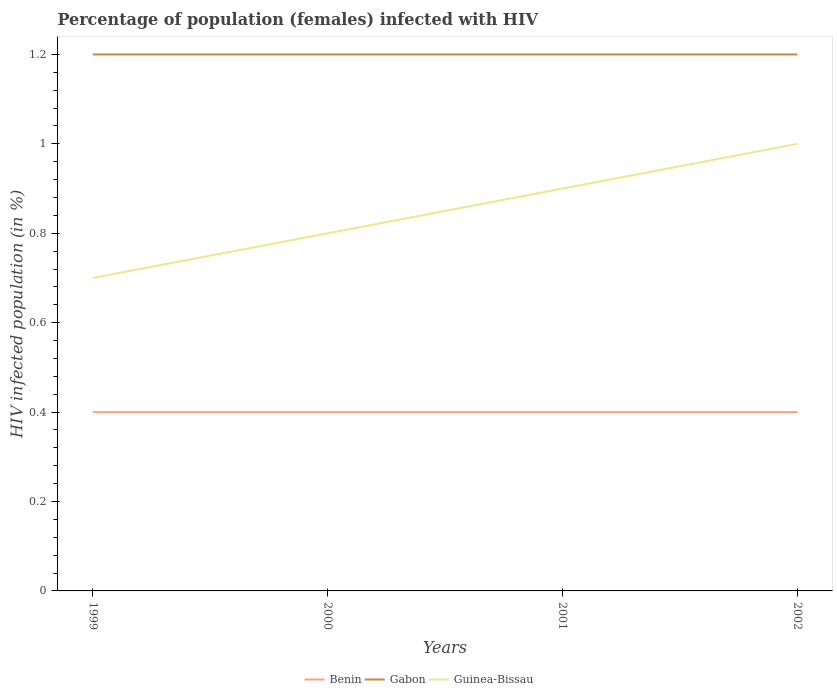Does the line corresponding to Gabon intersect with the line corresponding to Guinea-Bissau?
Your answer should be very brief. No. What is the total percentage of HIV infected female population in Benin in the graph?
Your answer should be very brief. 0. What is the difference between the highest and the second highest percentage of HIV infected female population in Guinea-Bissau?
Offer a very short reply. 0.3. What is the difference between the highest and the lowest percentage of HIV infected female population in Guinea-Bissau?
Ensure brevity in your answer.  2. Is the percentage of HIV infected female population in Guinea-Bissau strictly greater than the percentage of HIV infected female population in Gabon over the years?
Your response must be concise. Yes. Are the values on the major ticks of Y-axis written in scientific E-notation?
Your answer should be compact. No. Does the graph contain any zero values?
Your answer should be very brief. No. How are the legend labels stacked?
Provide a succinct answer. Horizontal. What is the title of the graph?
Your response must be concise. Percentage of population (females) infected with HIV. What is the label or title of the X-axis?
Your answer should be compact. Years. What is the label or title of the Y-axis?
Offer a terse response. HIV infected population (in %). What is the HIV infected population (in %) in Guinea-Bissau in 1999?
Provide a short and direct response. 0.7. What is the HIV infected population (in %) in Benin in 2000?
Offer a terse response. 0.4. What is the HIV infected population (in %) in Gabon in 2001?
Make the answer very short. 1.2. What is the HIV infected population (in %) of Guinea-Bissau in 2001?
Keep it short and to the point. 0.9. What is the HIV infected population (in %) in Guinea-Bissau in 2002?
Your answer should be compact. 1. Across all years, what is the maximum HIV infected population (in %) of Guinea-Bissau?
Your answer should be very brief. 1. Across all years, what is the minimum HIV infected population (in %) in Benin?
Provide a succinct answer. 0.4. Across all years, what is the minimum HIV infected population (in %) of Gabon?
Provide a short and direct response. 1.2. What is the total HIV infected population (in %) of Gabon in the graph?
Make the answer very short. 4.8. What is the difference between the HIV infected population (in %) of Benin in 1999 and that in 2000?
Ensure brevity in your answer.  0. What is the difference between the HIV infected population (in %) in Gabon in 1999 and that in 2000?
Provide a short and direct response. 0. What is the difference between the HIV infected population (in %) of Benin in 1999 and that in 2001?
Offer a very short reply. 0. What is the difference between the HIV infected population (in %) in Benin in 1999 and that in 2002?
Keep it short and to the point. 0. What is the difference between the HIV infected population (in %) of Gabon in 1999 and that in 2002?
Ensure brevity in your answer.  0. What is the difference between the HIV infected population (in %) in Benin in 2000 and that in 2001?
Provide a short and direct response. 0. What is the difference between the HIV infected population (in %) of Guinea-Bissau in 2000 and that in 2001?
Keep it short and to the point. -0.1. What is the difference between the HIV infected population (in %) of Guinea-Bissau in 2000 and that in 2002?
Provide a short and direct response. -0.2. What is the difference between the HIV infected population (in %) in Benin in 2001 and that in 2002?
Provide a short and direct response. 0. What is the difference between the HIV infected population (in %) in Gabon in 2001 and that in 2002?
Keep it short and to the point. 0. What is the difference between the HIV infected population (in %) of Benin in 1999 and the HIV infected population (in %) of Guinea-Bissau in 2000?
Give a very brief answer. -0.4. What is the difference between the HIV infected population (in %) of Benin in 1999 and the HIV infected population (in %) of Gabon in 2001?
Provide a short and direct response. -0.8. What is the difference between the HIV infected population (in %) of Benin in 1999 and the HIV infected population (in %) of Guinea-Bissau in 2001?
Provide a short and direct response. -0.5. What is the difference between the HIV infected population (in %) of Gabon in 1999 and the HIV infected population (in %) of Guinea-Bissau in 2001?
Ensure brevity in your answer.  0.3. What is the difference between the HIV infected population (in %) of Benin in 1999 and the HIV infected population (in %) of Guinea-Bissau in 2002?
Ensure brevity in your answer.  -0.6. What is the difference between the HIV infected population (in %) in Gabon in 1999 and the HIV infected population (in %) in Guinea-Bissau in 2002?
Your answer should be very brief. 0.2. What is the difference between the HIV infected population (in %) of Benin in 2000 and the HIV infected population (in %) of Gabon in 2001?
Your response must be concise. -0.8. What is the difference between the HIV infected population (in %) of Benin in 2000 and the HIV infected population (in %) of Guinea-Bissau in 2001?
Your response must be concise. -0.5. What is the difference between the HIV infected population (in %) of Gabon in 2000 and the HIV infected population (in %) of Guinea-Bissau in 2001?
Give a very brief answer. 0.3. What is the difference between the HIV infected population (in %) of Benin in 2000 and the HIV infected population (in %) of Gabon in 2002?
Keep it short and to the point. -0.8. What is the difference between the HIV infected population (in %) in Benin in 2000 and the HIV infected population (in %) in Guinea-Bissau in 2002?
Make the answer very short. -0.6. What is the difference between the HIV infected population (in %) in Gabon in 2000 and the HIV infected population (in %) in Guinea-Bissau in 2002?
Ensure brevity in your answer.  0.2. What is the average HIV infected population (in %) of Guinea-Bissau per year?
Offer a very short reply. 0.85. In the year 1999, what is the difference between the HIV infected population (in %) of Benin and HIV infected population (in %) of Gabon?
Provide a succinct answer. -0.8. In the year 1999, what is the difference between the HIV infected population (in %) in Gabon and HIV infected population (in %) in Guinea-Bissau?
Offer a very short reply. 0.5. In the year 2000, what is the difference between the HIV infected population (in %) of Benin and HIV infected population (in %) of Gabon?
Offer a terse response. -0.8. In the year 2001, what is the difference between the HIV infected population (in %) of Benin and HIV infected population (in %) of Guinea-Bissau?
Make the answer very short. -0.5. In the year 2001, what is the difference between the HIV infected population (in %) in Gabon and HIV infected population (in %) in Guinea-Bissau?
Your answer should be very brief. 0.3. In the year 2002, what is the difference between the HIV infected population (in %) of Benin and HIV infected population (in %) of Gabon?
Provide a succinct answer. -0.8. In the year 2002, what is the difference between the HIV infected population (in %) of Gabon and HIV infected population (in %) of Guinea-Bissau?
Your answer should be compact. 0.2. What is the ratio of the HIV infected population (in %) in Gabon in 1999 to that in 2001?
Give a very brief answer. 1. What is the ratio of the HIV infected population (in %) in Guinea-Bissau in 1999 to that in 2001?
Provide a succinct answer. 0.78. What is the ratio of the HIV infected population (in %) of Benin in 1999 to that in 2002?
Provide a short and direct response. 1. What is the ratio of the HIV infected population (in %) of Gabon in 1999 to that in 2002?
Keep it short and to the point. 1. What is the ratio of the HIV infected population (in %) in Gabon in 2000 to that in 2001?
Provide a succinct answer. 1. What is the ratio of the HIV infected population (in %) of Guinea-Bissau in 2000 to that in 2001?
Your response must be concise. 0.89. What is the ratio of the HIV infected population (in %) in Benin in 2000 to that in 2002?
Provide a short and direct response. 1. What is the ratio of the HIV infected population (in %) in Benin in 2001 to that in 2002?
Keep it short and to the point. 1. What is the difference between the highest and the second highest HIV infected population (in %) of Benin?
Your response must be concise. 0. What is the difference between the highest and the second highest HIV infected population (in %) of Guinea-Bissau?
Keep it short and to the point. 0.1. What is the difference between the highest and the lowest HIV infected population (in %) of Guinea-Bissau?
Offer a very short reply. 0.3. 